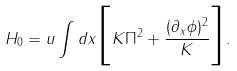Convert formula to latex. <formula><loc_0><loc_0><loc_500><loc_500>H _ { 0 } = u \int d x \Big { [ } K \Pi ^ { 2 } + \frac { ( \partial _ { x } \phi ) ^ { 2 } } { K } \Big { ] } .</formula> 